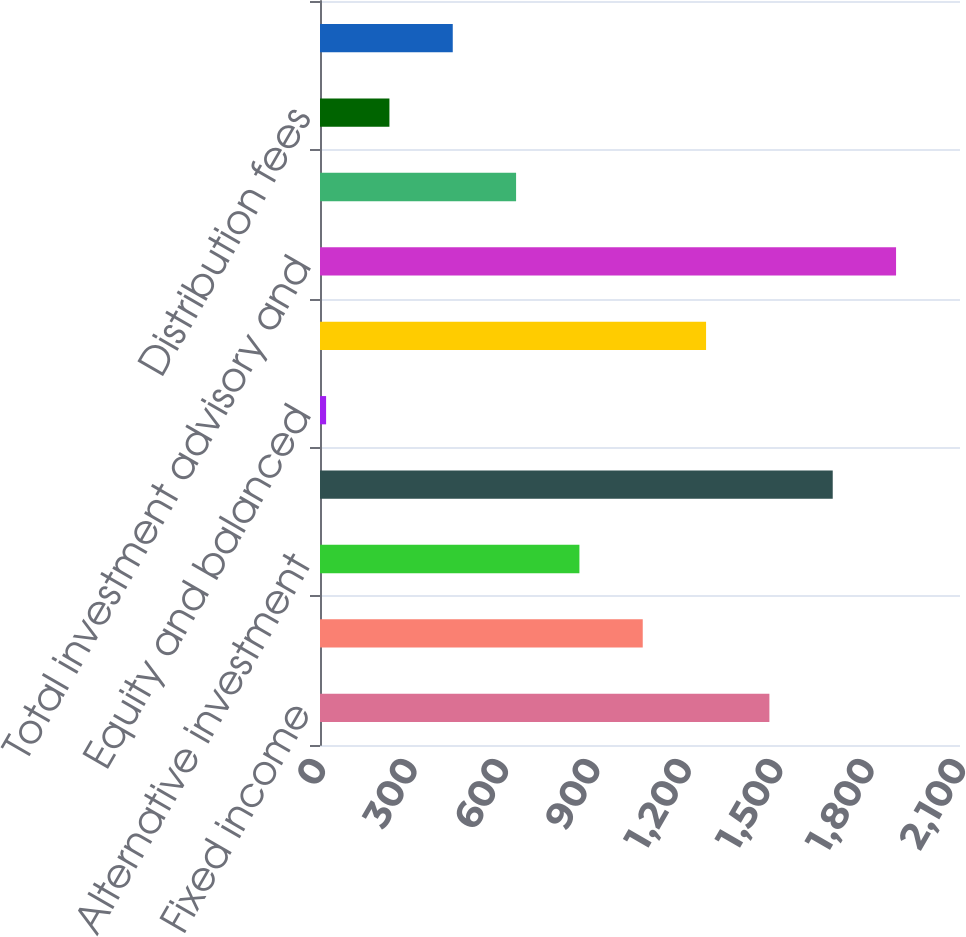Convert chart to OTSL. <chart><loc_0><loc_0><loc_500><loc_500><bar_chart><fcel>Fixed income<fcel>Cash management<fcel>Alternative investment<fcel>Investment advisory and<fcel>Equity and balanced<fcel>Investment advisory<fcel>Total investment advisory and<fcel>BlackRock Solutions and<fcel>Distribution fees<fcel>Other revenue<nl><fcel>1474.6<fcel>1059<fcel>851.2<fcel>1682.4<fcel>20<fcel>1266.8<fcel>1890.2<fcel>643.4<fcel>227.8<fcel>435.6<nl></chart> 